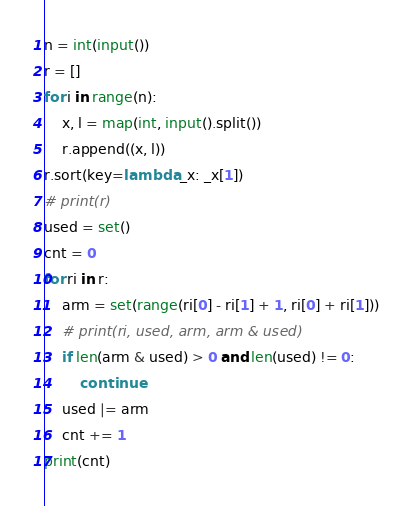<code> <loc_0><loc_0><loc_500><loc_500><_Python_>n = int(input())
r = []
for i in range(n):
    x, l = map(int, input().split())
    r.append((x, l))
r.sort(key=lambda _x: _x[1])
# print(r)
used = set()
cnt = 0
for ri in r:
    arm = set(range(ri[0] - ri[1] + 1, ri[0] + ri[1]))
    # print(ri, used, arm, arm & used)
    if len(arm & used) > 0 and len(used) != 0:
        continue
    used |= arm
    cnt += 1
print(cnt)</code> 